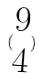<formula> <loc_0><loc_0><loc_500><loc_500>( \begin{matrix} 9 \\ 4 \end{matrix} )</formula> 